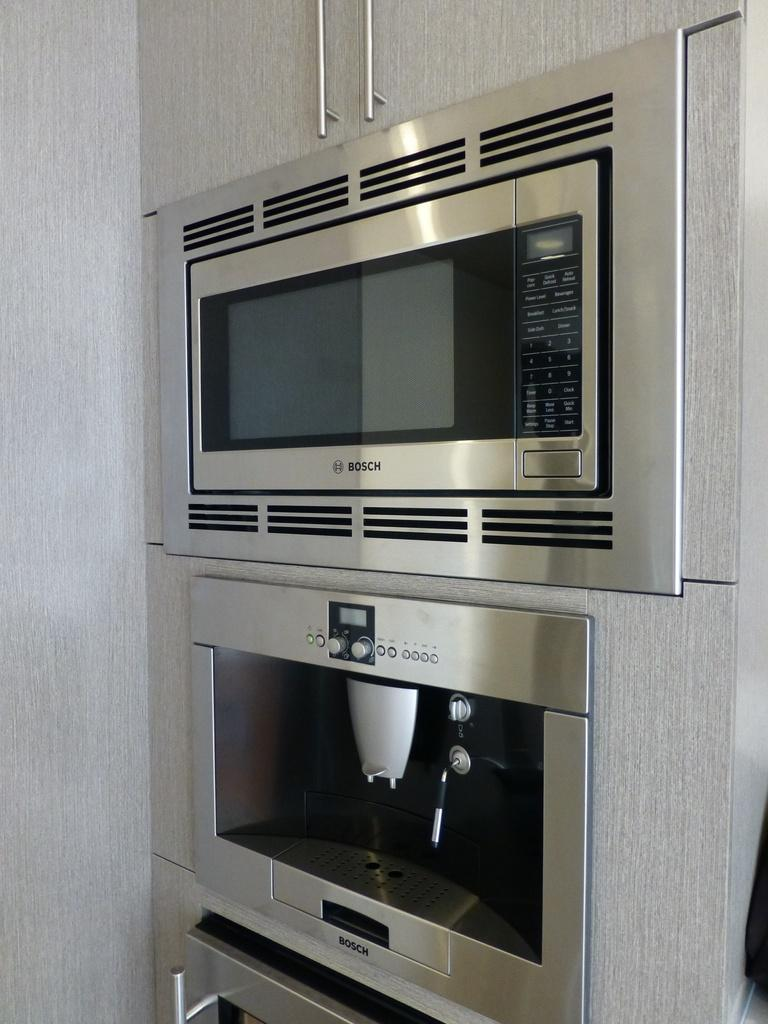<image>
Present a compact description of the photo's key features. A Bosch microwave and stove clean and looking brand new. 